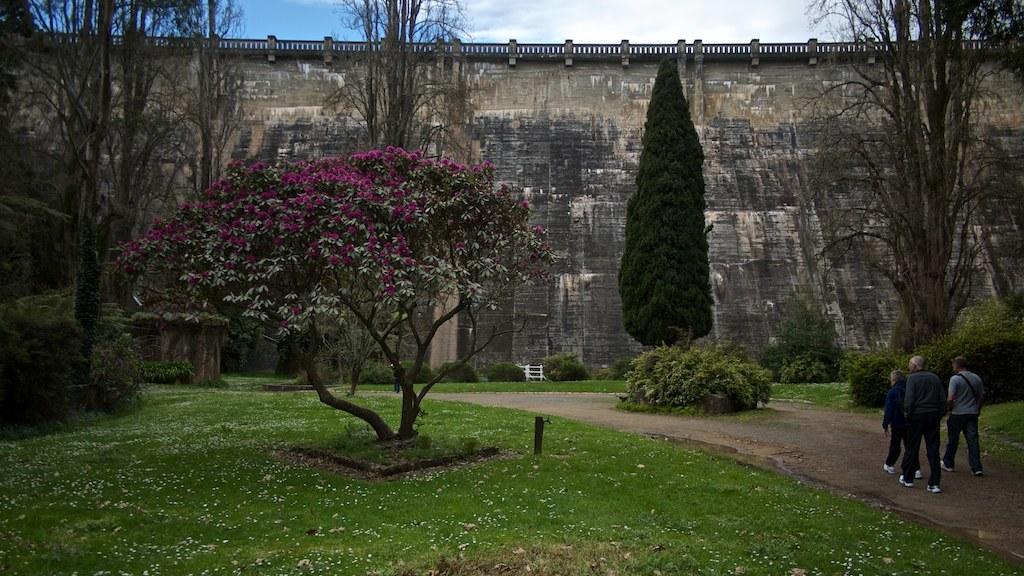Can you describe this image briefly? In this picture we can see three people walking on the ground, grass, trees, wall, fence, some objects and in the background we can see the sky. 